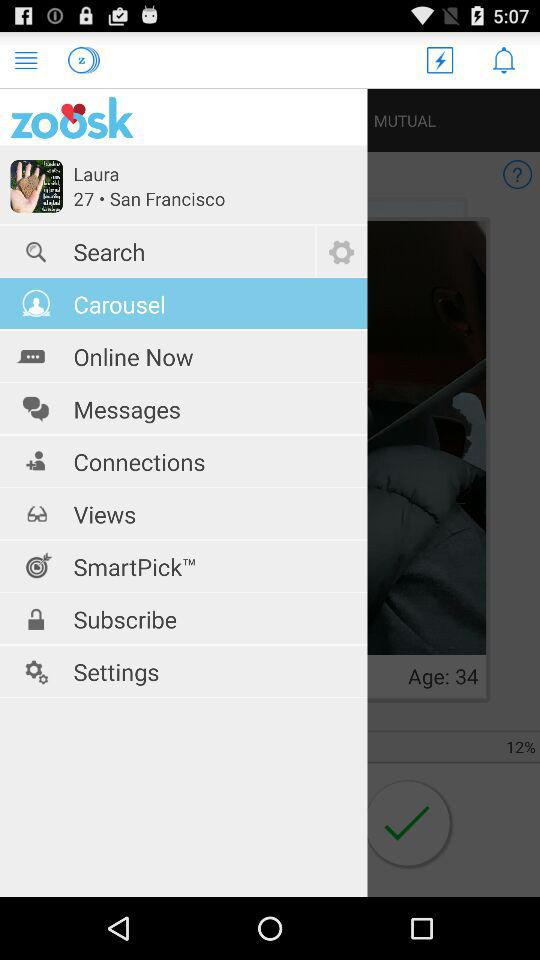What is the profile name? The profile name is Laura. 